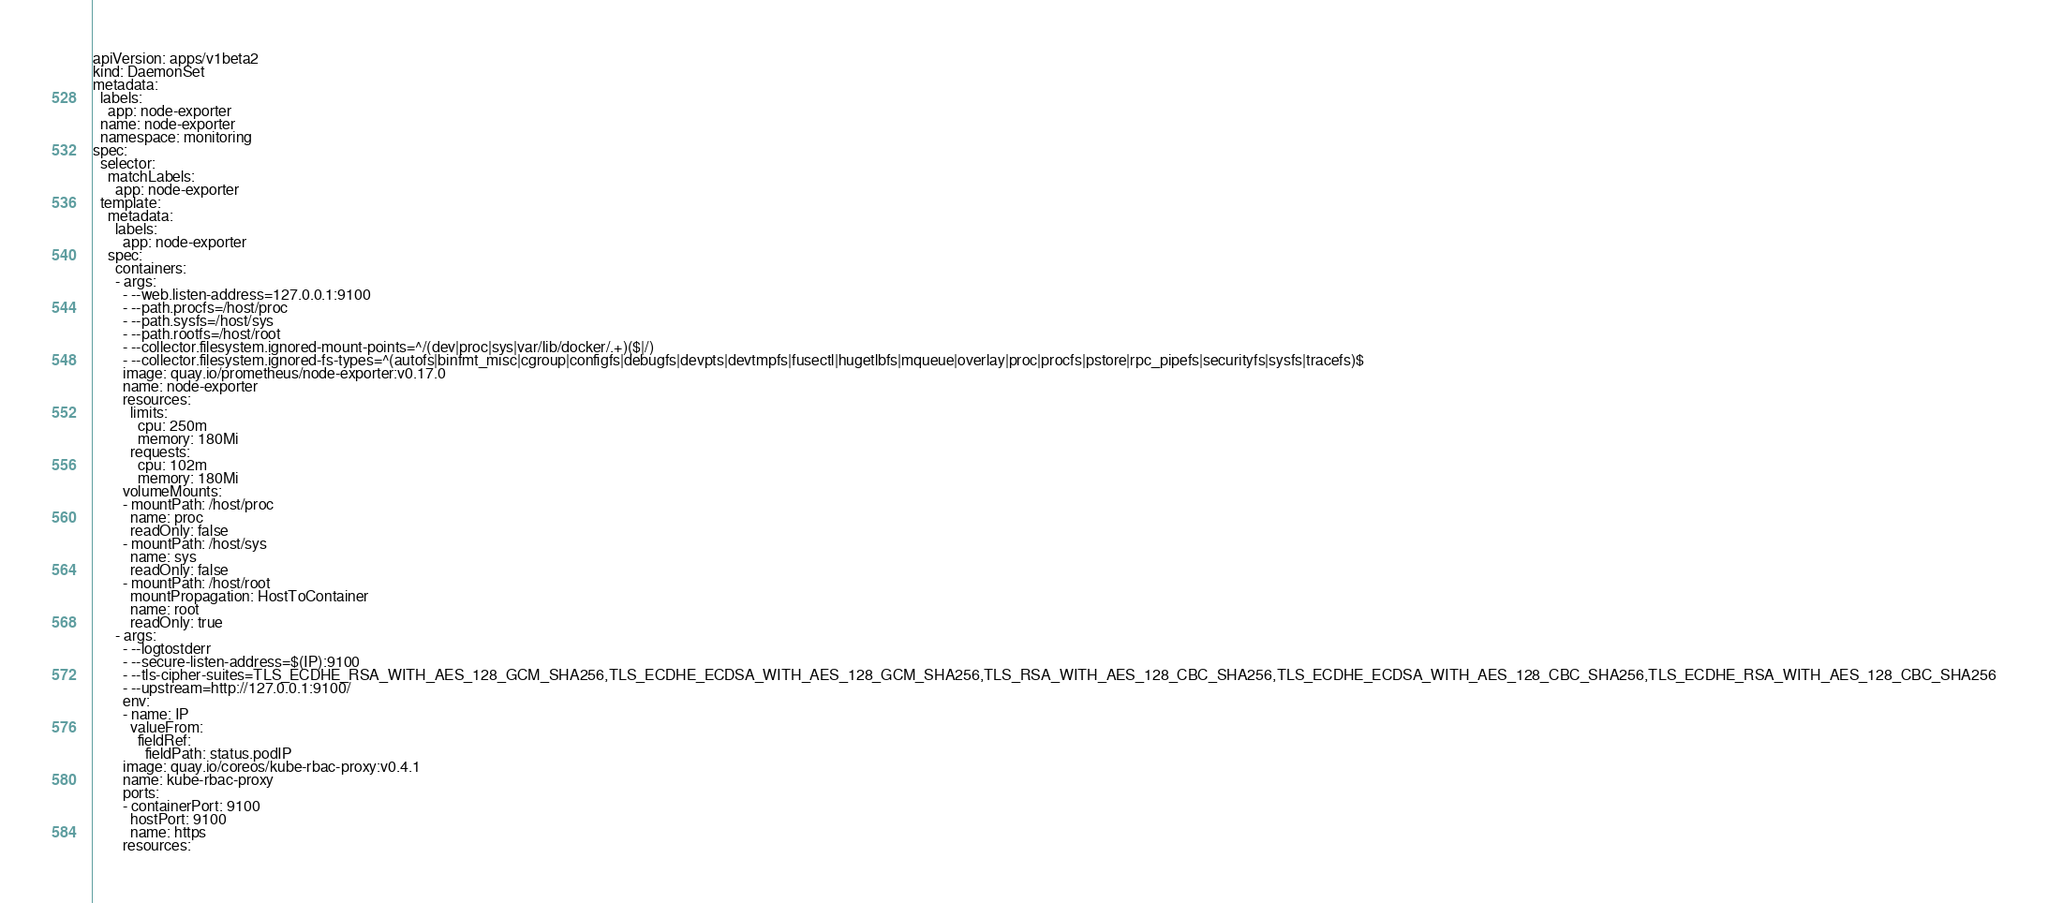Convert code to text. <code><loc_0><loc_0><loc_500><loc_500><_YAML_>apiVersion: apps/v1beta2
kind: DaemonSet
metadata:
  labels:
    app: node-exporter
  name: node-exporter
  namespace: monitoring
spec:
  selector:
    matchLabels:
      app: node-exporter
  template:
    metadata:
      labels:
        app: node-exporter
    spec:
      containers:
      - args:
        - --web.listen-address=127.0.0.1:9100
        - --path.procfs=/host/proc
        - --path.sysfs=/host/sys
        - --path.rootfs=/host/root
        - --collector.filesystem.ignored-mount-points=^/(dev|proc|sys|var/lib/docker/.+)($|/)
        - --collector.filesystem.ignored-fs-types=^(autofs|binfmt_misc|cgroup|configfs|debugfs|devpts|devtmpfs|fusectl|hugetlbfs|mqueue|overlay|proc|procfs|pstore|rpc_pipefs|securityfs|sysfs|tracefs)$
        image: quay.io/prometheus/node-exporter:v0.17.0
        name: node-exporter
        resources:
          limits:
            cpu: 250m
            memory: 180Mi
          requests:
            cpu: 102m
            memory: 180Mi
        volumeMounts:
        - mountPath: /host/proc
          name: proc
          readOnly: false
        - mountPath: /host/sys
          name: sys
          readOnly: false
        - mountPath: /host/root
          mountPropagation: HostToContainer
          name: root
          readOnly: true
      - args:
        - --logtostderr
        - --secure-listen-address=$(IP):9100
        - --tls-cipher-suites=TLS_ECDHE_RSA_WITH_AES_128_GCM_SHA256,TLS_ECDHE_ECDSA_WITH_AES_128_GCM_SHA256,TLS_RSA_WITH_AES_128_CBC_SHA256,TLS_ECDHE_ECDSA_WITH_AES_128_CBC_SHA256,TLS_ECDHE_RSA_WITH_AES_128_CBC_SHA256
        - --upstream=http://127.0.0.1:9100/
        env:
        - name: IP
          valueFrom:
            fieldRef:
              fieldPath: status.podIP
        image: quay.io/coreos/kube-rbac-proxy:v0.4.1
        name: kube-rbac-proxy
        ports:
        - containerPort: 9100
          hostPort: 9100
          name: https
        resources:</code> 